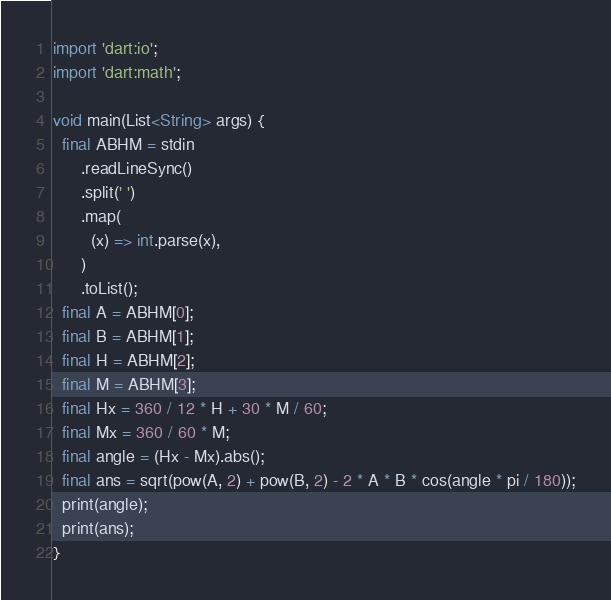Convert code to text. <code><loc_0><loc_0><loc_500><loc_500><_Dart_>import 'dart:io';
import 'dart:math';

void main(List<String> args) {
  final ABHM = stdin
      .readLineSync()
      .split(' ')
      .map(
        (x) => int.parse(x),
      )
      .toList();
  final A = ABHM[0];
  final B = ABHM[1];
  final H = ABHM[2];
  final M = ABHM[3];
  final Hx = 360 / 12 * H + 30 * M / 60;
  final Mx = 360 / 60 * M;
  final angle = (Hx - Mx).abs();
  final ans = sqrt(pow(A, 2) + pow(B, 2) - 2 * A * B * cos(angle * pi / 180));
  print(angle);
  print(ans);
}
</code> 